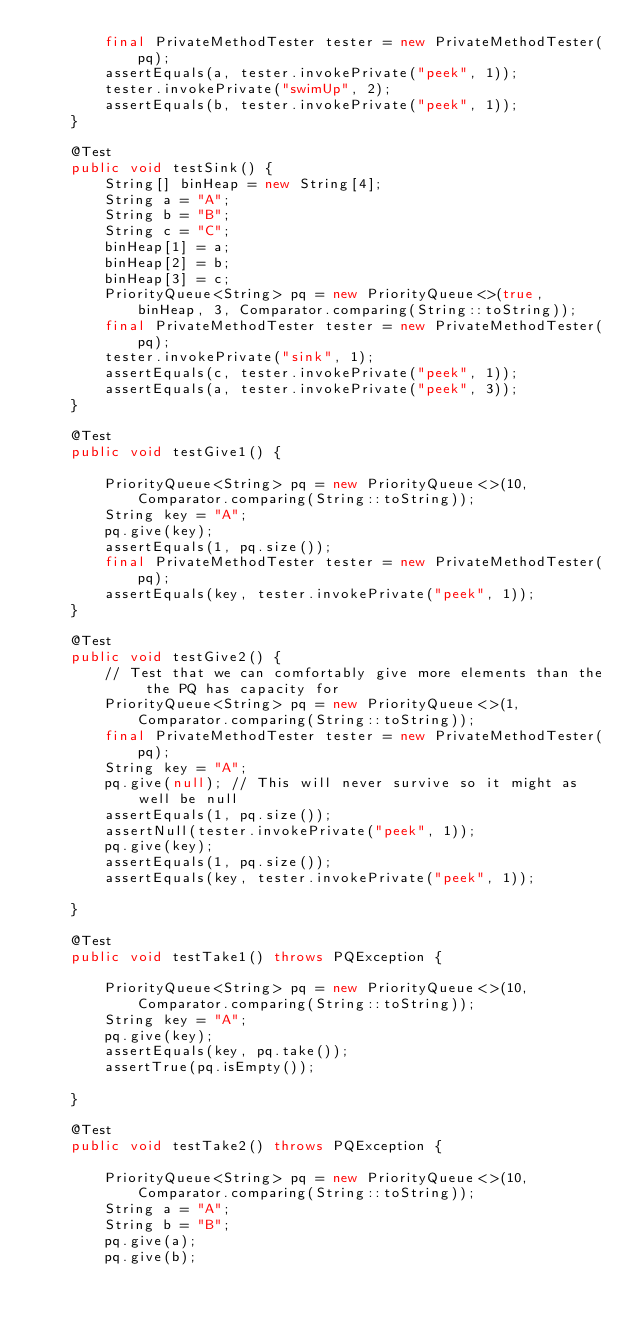Convert code to text. <code><loc_0><loc_0><loc_500><loc_500><_Java_>        final PrivateMethodTester tester = new PrivateMethodTester(pq);
        assertEquals(a, tester.invokePrivate("peek", 1));
        tester.invokePrivate("swimUp", 2);
        assertEquals(b, tester.invokePrivate("peek", 1));
    }

    @Test
    public void testSink() {
        String[] binHeap = new String[4];
        String a = "A";
        String b = "B";
        String c = "C";
        binHeap[1] = a;
        binHeap[2] = b;
        binHeap[3] = c;
        PriorityQueue<String> pq = new PriorityQueue<>(true, binHeap, 3, Comparator.comparing(String::toString));
        final PrivateMethodTester tester = new PrivateMethodTester(pq);
        tester.invokePrivate("sink", 1);
        assertEquals(c, tester.invokePrivate("peek", 1));
        assertEquals(a, tester.invokePrivate("peek", 3));
    }

    @Test
    public void testGive1() {

        PriorityQueue<String> pq = new PriorityQueue<>(10, Comparator.comparing(String::toString));
        String key = "A";
        pq.give(key);
        assertEquals(1, pq.size());
        final PrivateMethodTester tester = new PrivateMethodTester(pq);
        assertEquals(key, tester.invokePrivate("peek", 1));
    }

    @Test
    public void testGive2() {
        // Test that we can comfortably give more elements than the the PQ has capacity for
        PriorityQueue<String> pq = new PriorityQueue<>(1, Comparator.comparing(String::toString));
        final PrivateMethodTester tester = new PrivateMethodTester(pq);
        String key = "A";
        pq.give(null); // This will never survive so it might as well be null
        assertEquals(1, pq.size());
        assertNull(tester.invokePrivate("peek", 1));
        pq.give(key);
        assertEquals(1, pq.size());
        assertEquals(key, tester.invokePrivate("peek", 1));

    }

    @Test
    public void testTake1() throws PQException {

        PriorityQueue<String> pq = new PriorityQueue<>(10, Comparator.comparing(String::toString));
        String key = "A";
        pq.give(key);
        assertEquals(key, pq.take());
        assertTrue(pq.isEmpty());

    }

    @Test
    public void testTake2() throws PQException {

        PriorityQueue<String> pq = new PriorityQueue<>(10, Comparator.comparing(String::toString));
        String a = "A";
        String b = "B";
        pq.give(a);
        pq.give(b);</code> 